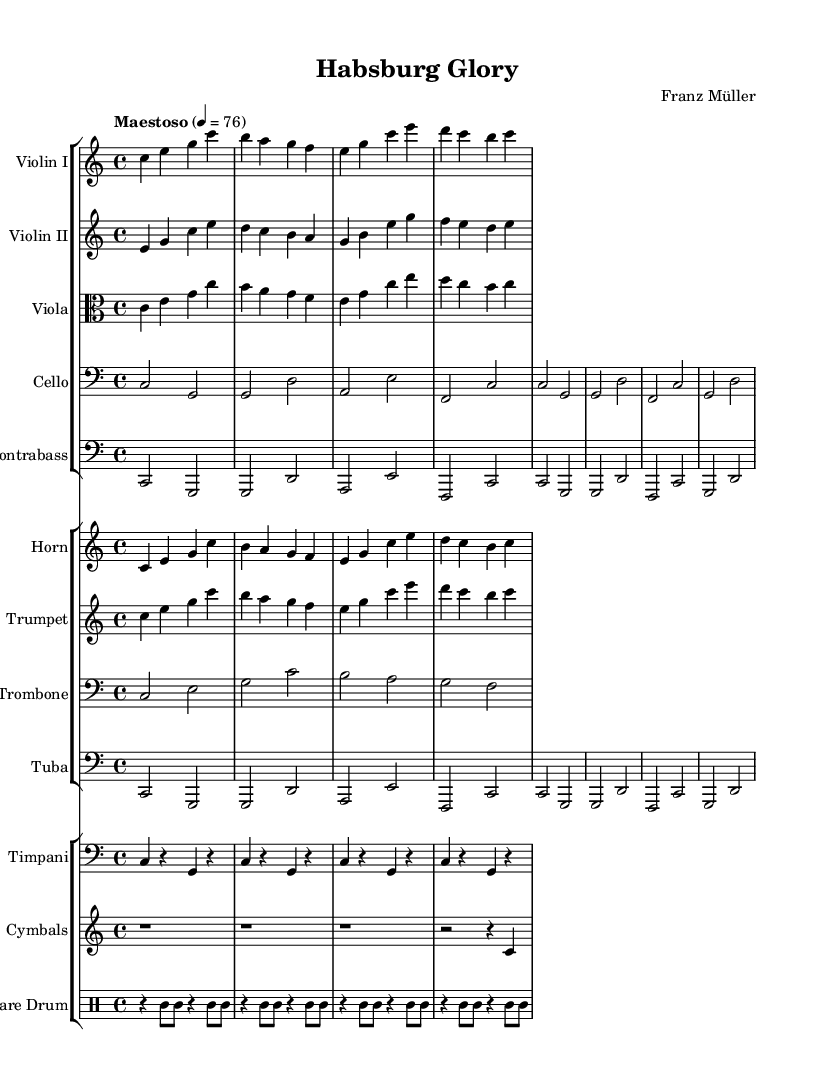What is the key signature of this music? The key signature is C major, which has no sharps or flats indicated in the music. This can be identified by looking for the absence of any sharp or flat symbols at the beginning of the staff.
Answer: C major What is the time signature of this music? The time signature is 4/4, which can be seen at the beginning of the staff. This indicates that there are four beats per measure and that a quarter note receives one beat.
Answer: 4/4 What is the tempo marking of this music? The tempo marking is "Maestoso" with a metronome indication of 76 beats per minute. This is specified in the score, showing both the style and tempo for the performance.
Answer: Maestoso How many instruments are featured in this score? There are ten instruments listed in the score, which can be counted by looking at the various staves provided for each instrument.
Answer: Ten Which brass instrument has the highest range in this score? The trumpet has the highest range among the brass instruments as it is written in the highest octave relative to the other brass instruments such as horn, trombone, and tuba.
Answer: Trumpet What kind of musical piece is this? This piece is an epic orchestral score, as indicated by the instrumentation and the style indicated by the tempo marking and overall score structure, which is commonly found in historical European films.
Answer: Epic orchestral score What is the first note of the violin I part? The first note of the violin I part is "C." This can be determined by looking at the first measure of the violin I staff.
Answer: C 